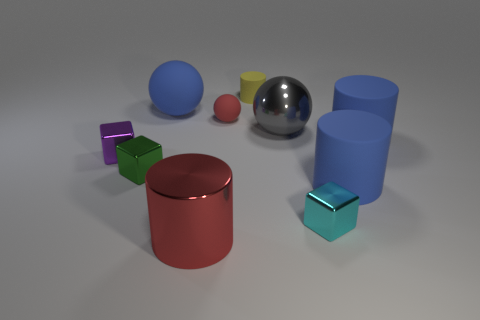Subtract all big red shiny cylinders. How many cylinders are left? 3 How many blue cylinders must be subtracted to get 1 blue cylinders? 1 Subtract 3 spheres. How many spheres are left? 0 Subtract all purple cubes. Subtract all green cylinders. How many cubes are left? 2 Subtract all red blocks. How many gray balls are left? 1 Subtract all large green objects. Subtract all small green objects. How many objects are left? 9 Add 5 cylinders. How many cylinders are left? 9 Add 3 small yellow blocks. How many small yellow blocks exist? 3 Subtract all gray balls. How many balls are left? 2 Subtract 0 cyan spheres. How many objects are left? 10 